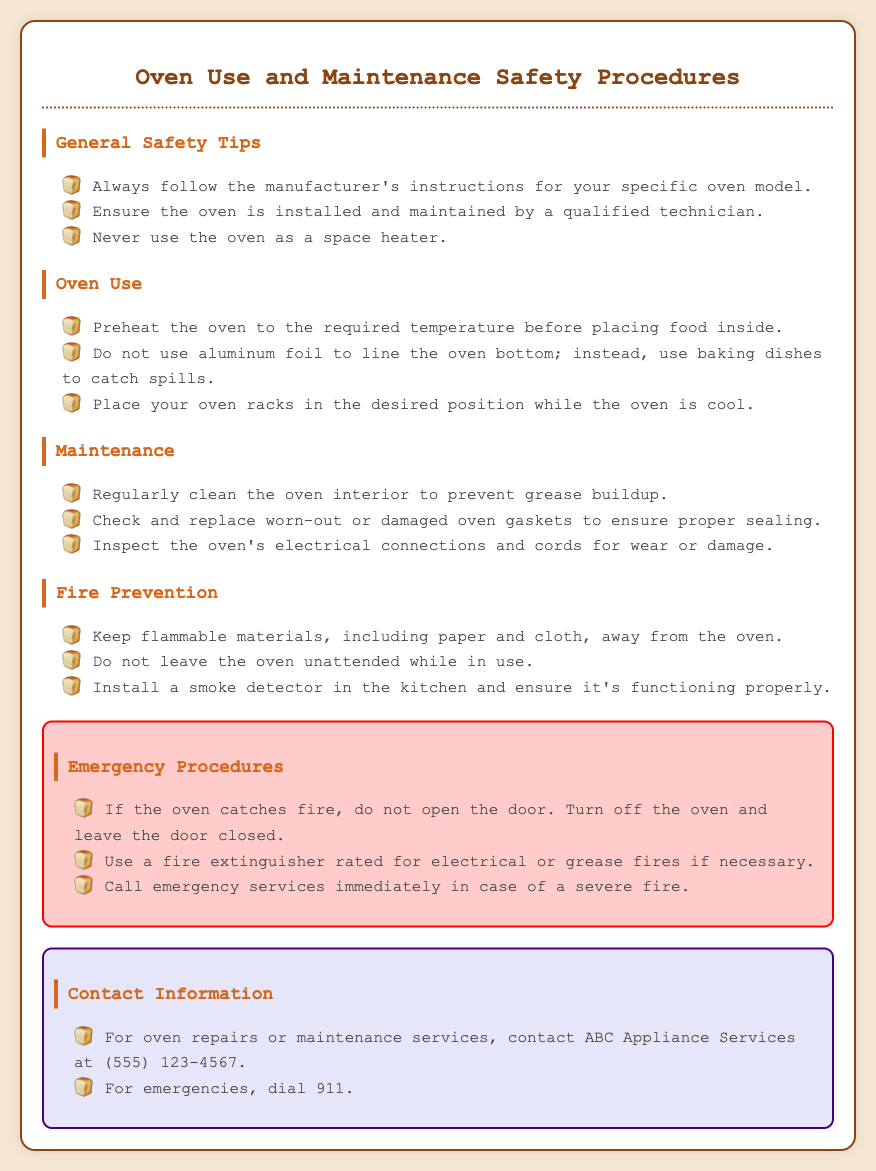What should you never use the oven as? The document advises not to use the oven as a space heater.
Answer: space heater What number should you call for oven repairs? The document states to contact ABC Appliance Services at (555) 123-4567 for repairs or maintenance services.
Answer: (555) 123-4567 What should you regularly check for wear or damage? The document indicates you should inspect the oven's electrical connections and cords for wear or damage.
Answer: electrical connections and cords What should you do if the oven catches fire? The document instructs to turn off the oven and leave the door closed if it catches fire.
Answer: turn off the oven and leave the door closed What is the emergency number to dial? The document mentions that for emergencies, you should dial 911.
Answer: 911 What is one way to prevent grease buildup? The document highlights that regularly cleaning the oven interior will help prevent grease buildup.
Answer: regularly clean the oven interior What type of materials should be kept away from the oven? The document emphasizes keeping flammable materials away from the oven.
Answer: flammable materials When should you place oven racks in the desired position? The document states to place oven racks in the desired position while the oven is cool.
Answer: while the oven is cool 